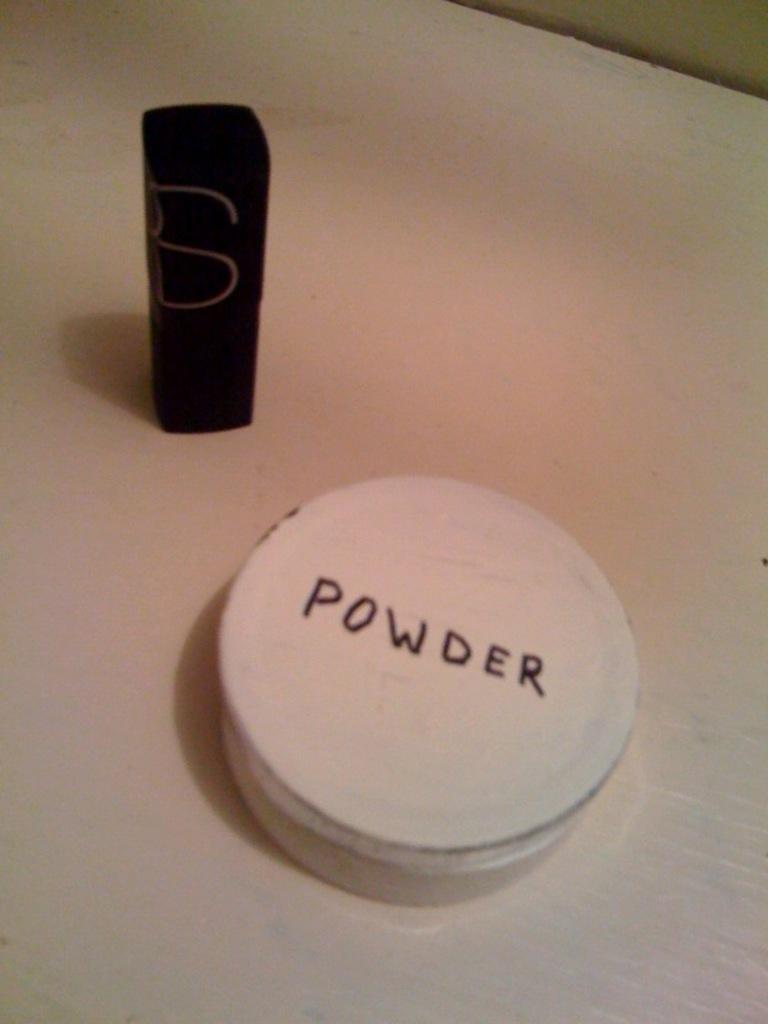What is on the lid of the white container?
Your answer should be very brief. Powder. 